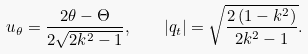Convert formula to latex. <formula><loc_0><loc_0><loc_500><loc_500>u _ { \theta } = \frac { 2 \theta - \Theta } { 2 \sqrt { 2 k ^ { 2 } - 1 } } , \quad | q _ { t } | = \sqrt { \frac { 2 \, ( 1 - k ^ { 2 } ) } { 2 k ^ { 2 } - 1 } } .</formula> 